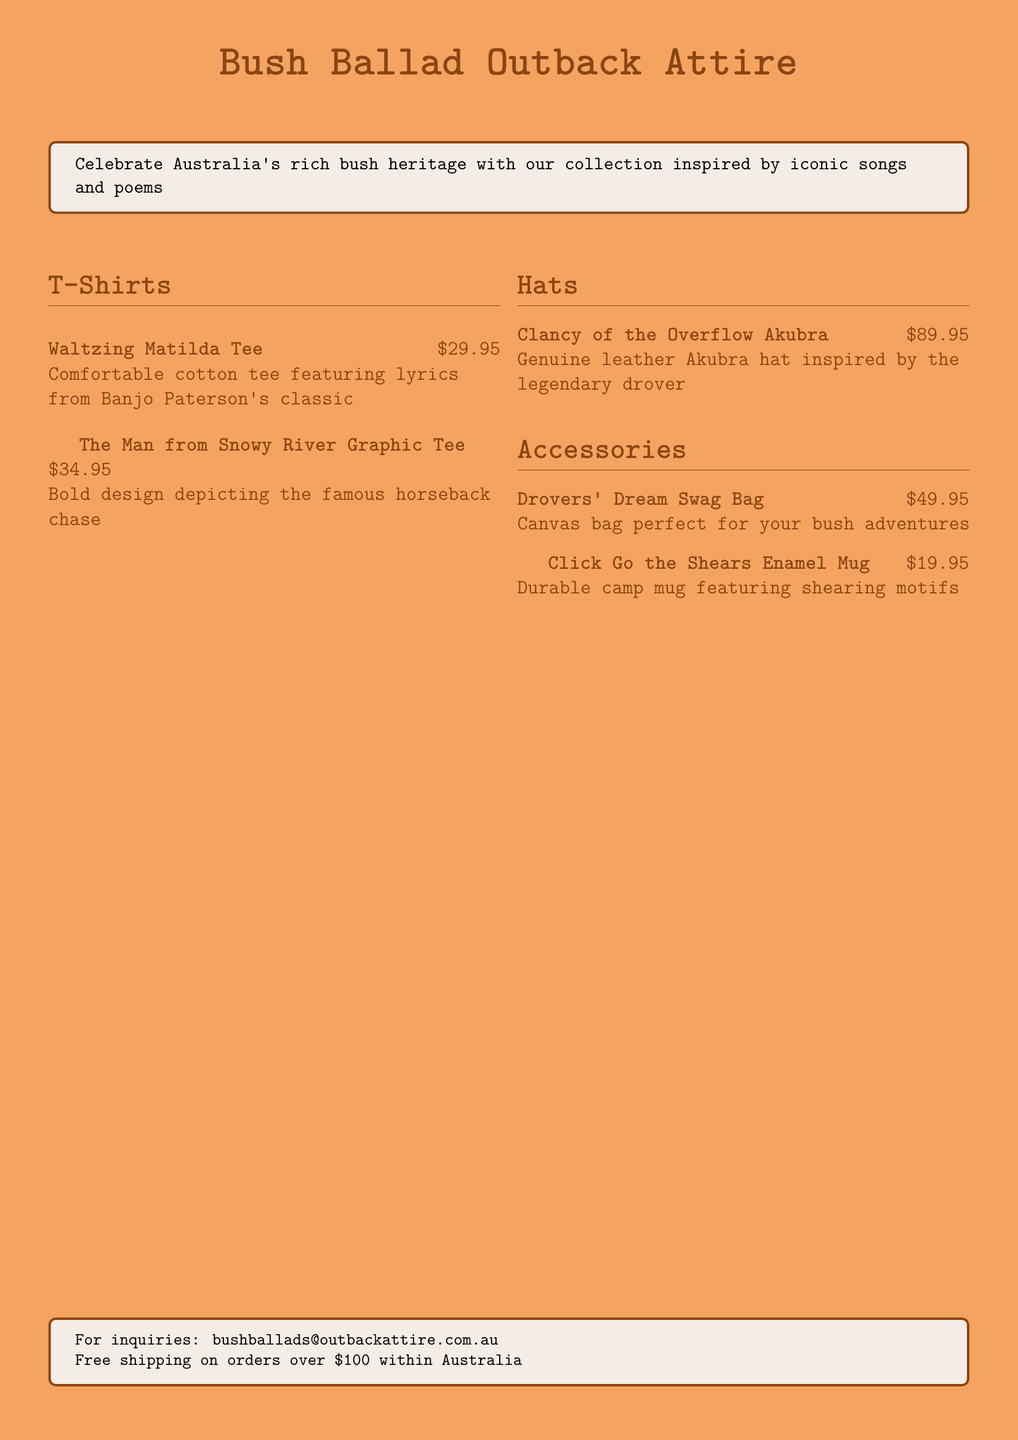What is the name of the tee featuring lyrics from Banjo Paterson's classic? The tee is called "Waltzing Matilda Tee," which is mentioned in the document under T-Shirts.
Answer: Waltzing Matilda Tee How much does the "Clancy of the Overflow Akubra" cost? The document lists the price of the Akubra hat as $89.95.
Answer: $89.95 What type of bag is the "Drovers' Dream Swag Bag"? The document describes it as a canvas bag suitable for bush adventures.
Answer: Canvas bag Which graphic tee depicts a famous horseback chase? The document refers to "The Man from Snowy River Graphic Tee" as the one with the bold design of the chase.
Answer: The Man from Snowy River Graphic Tee What is the price of the "Click Go the Shears Enamel Mug"? The price listed for the enamel mug in the document is $19.95.
Answer: $19.95 How many T-shirts are featured in the catalog? The catalog features two T-shirts, as listed under the T-Shirts section.
Answer: Two What is the main color theme of the catalog's background? The background color of the document is sandy beige, which is stated in the formatting section.
Answer: Sandy beige Which item is described as perfect for bush adventures? The "Drovers' Dream Swag Bag" is indicated as suitable for bush adventures in the Accessories section.
Answer: Drovers' Dream Swag Bag 